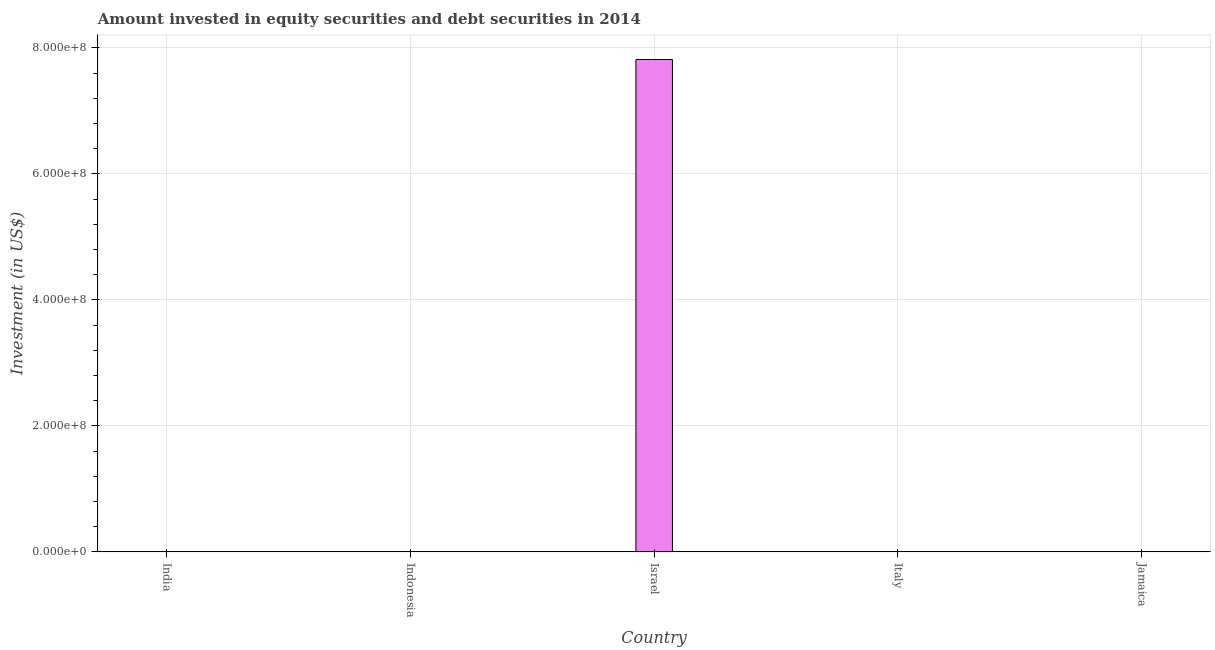What is the title of the graph?
Your response must be concise. Amount invested in equity securities and debt securities in 2014. What is the label or title of the X-axis?
Your answer should be very brief. Country. What is the label or title of the Y-axis?
Make the answer very short. Investment (in US$). Across all countries, what is the maximum portfolio investment?
Your answer should be very brief. 7.82e+08. What is the sum of the portfolio investment?
Ensure brevity in your answer.  7.82e+08. What is the average portfolio investment per country?
Provide a short and direct response. 1.56e+08. What is the median portfolio investment?
Your answer should be very brief. 0. What is the difference between the highest and the lowest portfolio investment?
Offer a very short reply. 7.82e+08. Are all the bars in the graph horizontal?
Make the answer very short. No. How many countries are there in the graph?
Give a very brief answer. 5. What is the Investment (in US$) in Israel?
Provide a succinct answer. 7.82e+08. What is the Investment (in US$) of Italy?
Offer a very short reply. 0. What is the Investment (in US$) in Jamaica?
Make the answer very short. 0. 